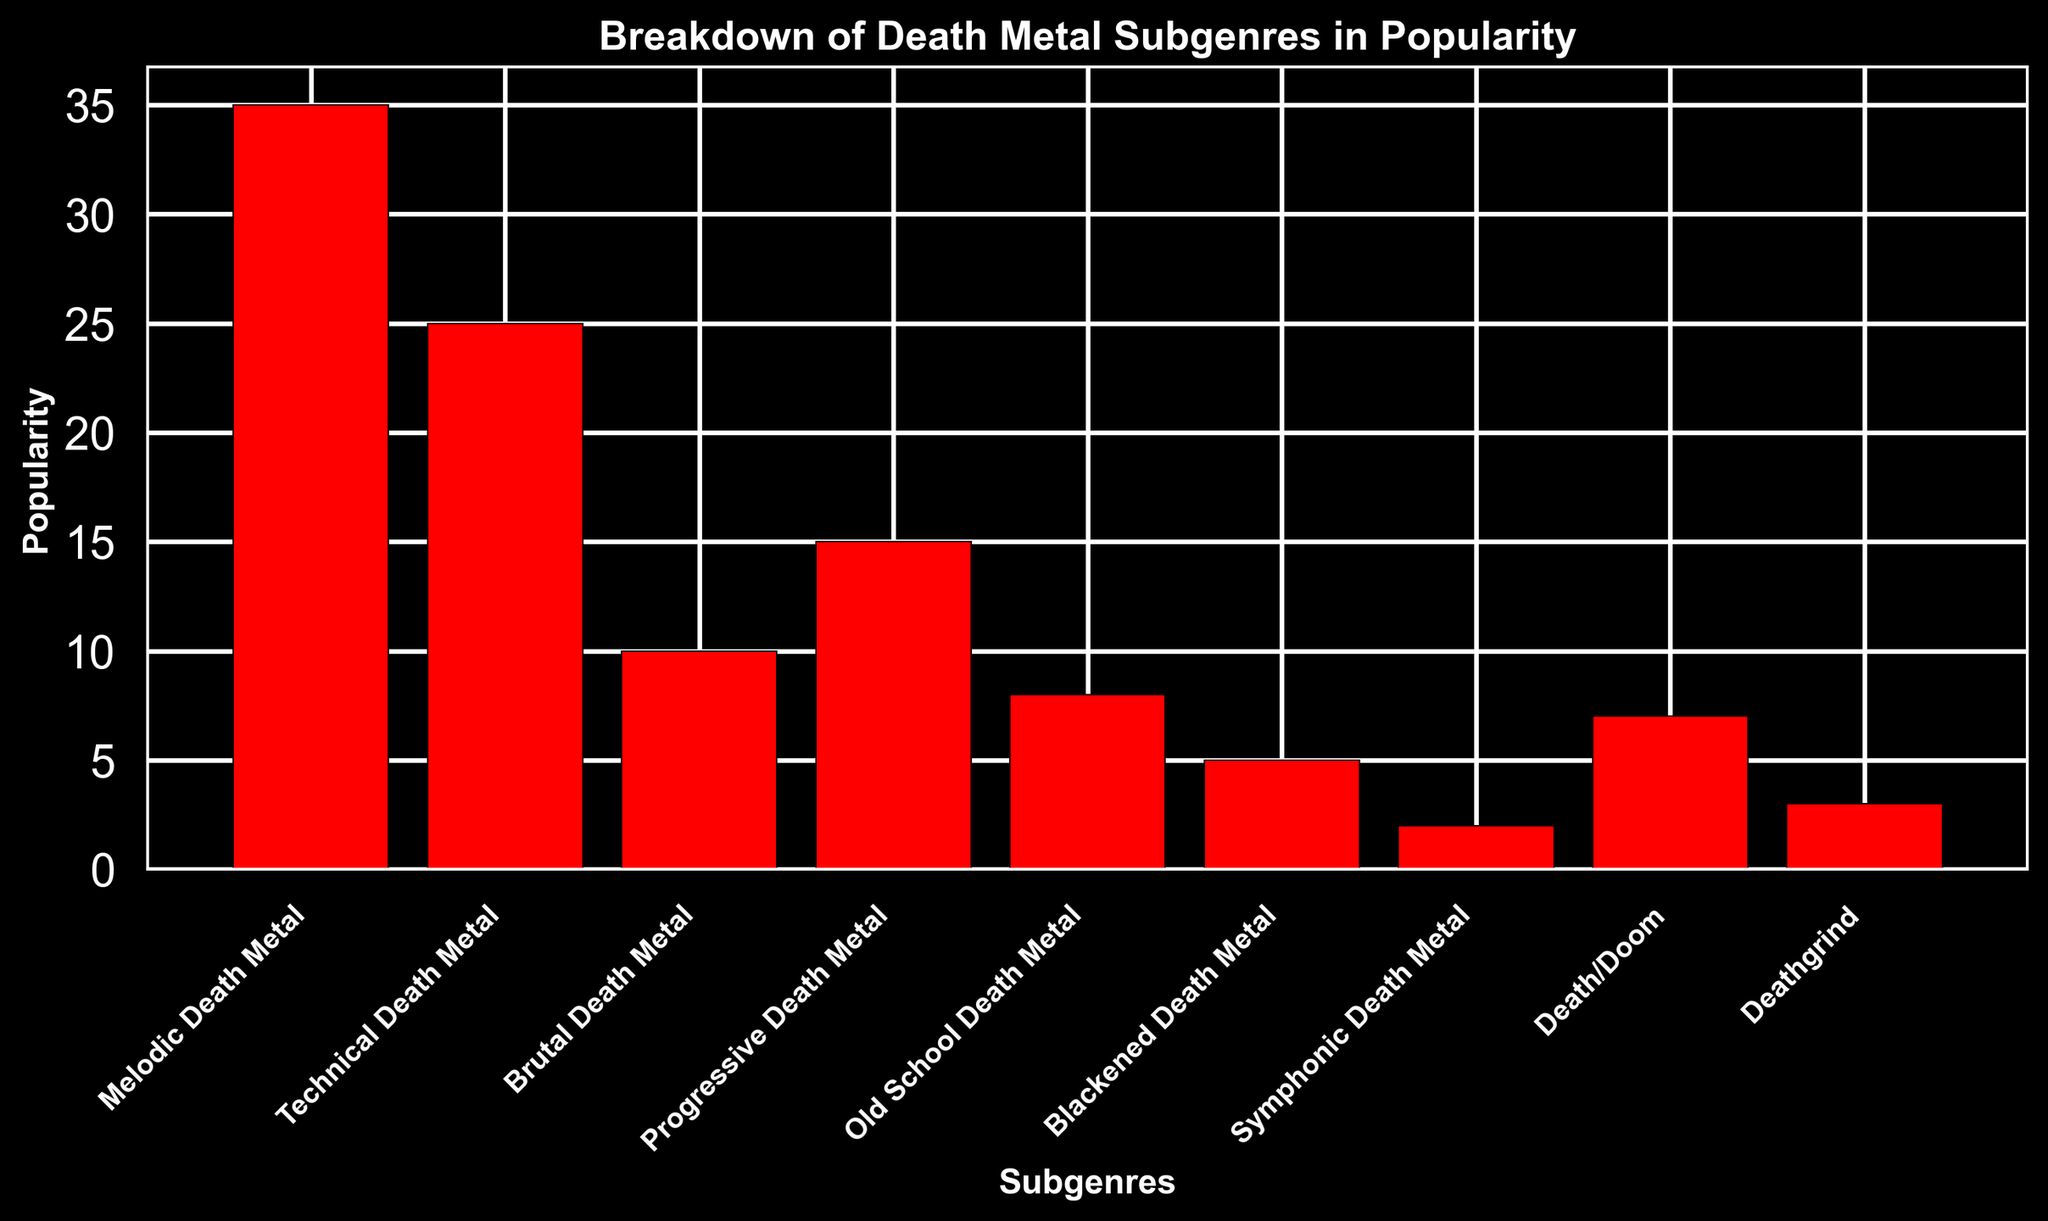Which subgenre has the highest popularity? The highest bar in the chart represents the subgenre with the highest popularity. By observing the bars, "Melodic Death Metal" has the tallest bar.
Answer: Melodic Death Metal What is the combined popularity of Deathgrind and Symphonic Death Metal? Locate the bars for "Deathgrind" and "Symphonic Death Metal". Their heights represent their popularity: 3 and 2 respectively. Summing these values gives 3 + 2 = 5.
Answer: 5 How much more popular is Technical Death Metal compared to Death/Doom? Find the bars representing "Technical Death Metal" and "Death/Doom". Their popularities are 25 and 7 respectively. Subtract the lower value from the higher: 25 - 7 = 18.
Answer: 18 Which subgenres have a popularity less than 10? Look at the heights of the bars to find those that are less than 10. These are "Old School Death Metal" (8), "Blackened Death Metal" (5), "Symphonic Death Metal" (2), "Death/Doom" (7), and "Deathgrind" (3).
Answer: Old School Death Metal, Blackened Death Metal, Symphonic Death Metal, Death/Doom, Deathgrind What is the average popularity of the subgenres? Sum the popularity of all subgenres: 35 + 25 + 10 + 15 + 8 + 5 + 2 + 7 + 3 = 110. Divide the total by the number of subgenres, which is 9: 110 / 9 ≈ 12.22.
Answer: 12.22 Which two subgenres have the closest popularity values? Compare the popularity values and identify the pair with the smallest difference. "Deathgrind" and "Symphonic Death Metal" differ by 1 (3 - 2). Other pairs have larger differences.
Answer: Deathgrind and Symphonic Death Metal What is the total popularity of subgenres that have at least 20 in popularity? Identify subgenres with a popularity of 20 or more: "Melodic Death Metal" (35) and "Technical Death Metal" (25). Sum these values: 35 + 25 = 60.
Answer: 60 Is Brutal Death Metal more or less popular than Progressive Death Metal? Compare the bar heights for "Brutal Death Metal" (10) and "Progressive Death Metal" (15). "Brutal Death Metal" is less popular.
Answer: Less popular Which subgenre has the least popularity? The shortest bar in the chart represents the subgenre with the least popularity. "Symphonic Death Metal" has the shortest bar with a popularity of 2.
Answer: Symphonic Death Metal 